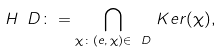Convert formula to latex. <formula><loc_0><loc_0><loc_500><loc_500>H _ { \ } D \colon = \bigcap _ { \chi \colon ( e , \, \chi ) \in \ D } \, K e r ( \chi ) ,</formula> 